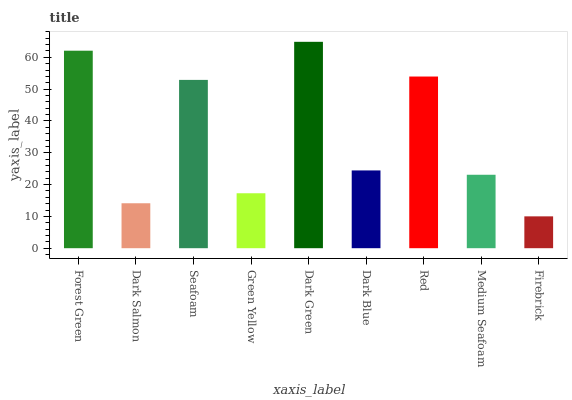Is Firebrick the minimum?
Answer yes or no. Yes. Is Dark Green the maximum?
Answer yes or no. Yes. Is Dark Salmon the minimum?
Answer yes or no. No. Is Dark Salmon the maximum?
Answer yes or no. No. Is Forest Green greater than Dark Salmon?
Answer yes or no. Yes. Is Dark Salmon less than Forest Green?
Answer yes or no. Yes. Is Dark Salmon greater than Forest Green?
Answer yes or no. No. Is Forest Green less than Dark Salmon?
Answer yes or no. No. Is Dark Blue the high median?
Answer yes or no. Yes. Is Dark Blue the low median?
Answer yes or no. Yes. Is Medium Seafoam the high median?
Answer yes or no. No. Is Firebrick the low median?
Answer yes or no. No. 